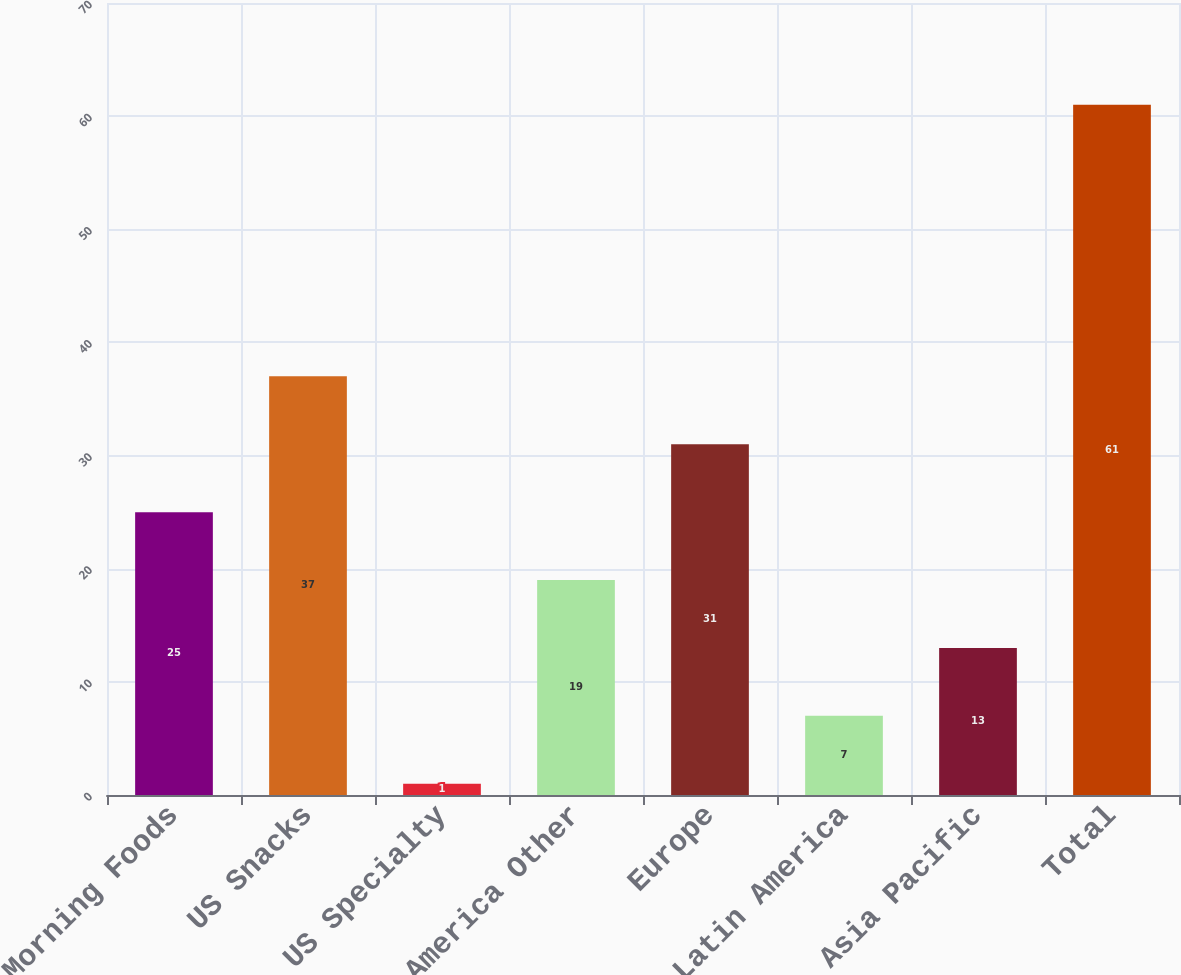Convert chart. <chart><loc_0><loc_0><loc_500><loc_500><bar_chart><fcel>US Morning Foods<fcel>US Snacks<fcel>US Specialty<fcel>North America Other<fcel>Europe<fcel>Latin America<fcel>Asia Pacific<fcel>Total<nl><fcel>25<fcel>37<fcel>1<fcel>19<fcel>31<fcel>7<fcel>13<fcel>61<nl></chart> 